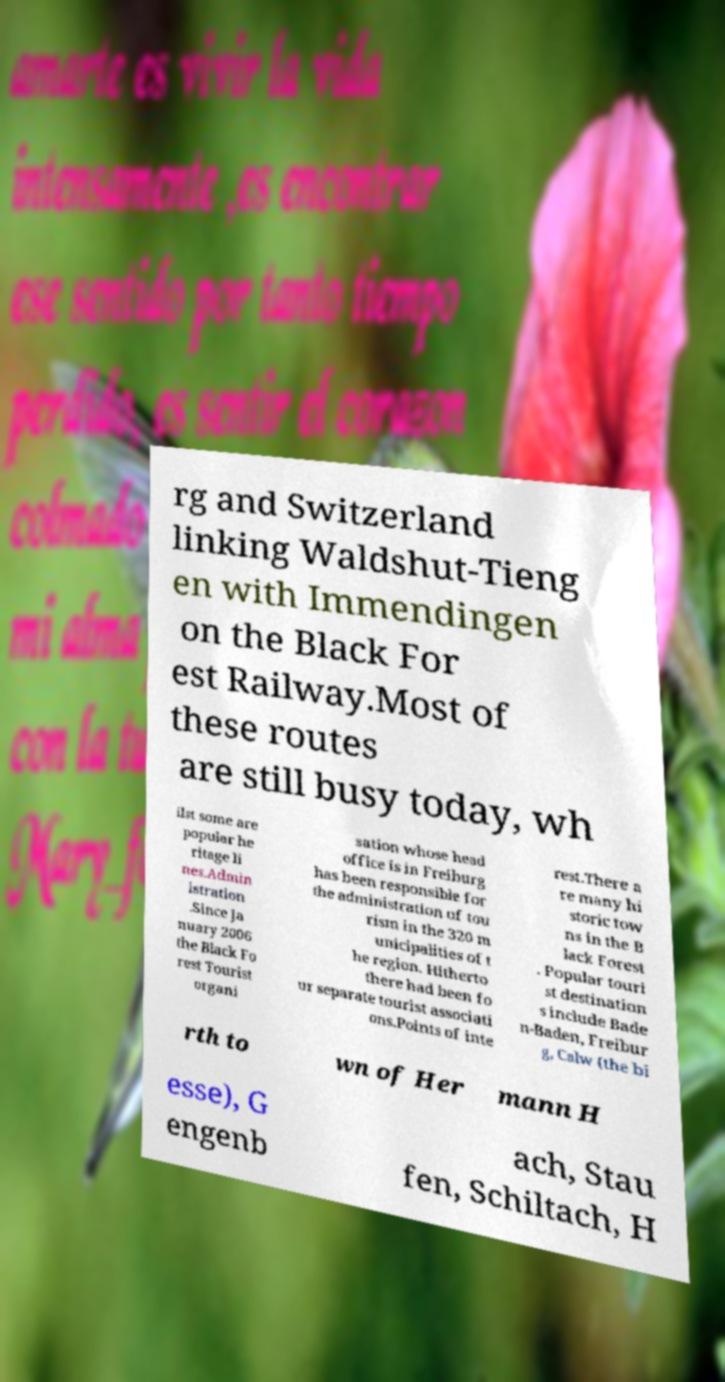Could you assist in decoding the text presented in this image and type it out clearly? rg and Switzerland linking Waldshut-Tieng en with Immendingen on the Black For est Railway.Most of these routes are still busy today, wh ilst some are popular he ritage li nes.Admin istration .Since Ja nuary 2006 the Black Fo rest Tourist organi sation whose head office is in Freiburg has been responsible for the administration of tou rism in the 320 m unicipalities of t he region. Hitherto there had been fo ur separate tourist associati ons.Points of inte rest.There a re many hi storic tow ns in the B lack Forest . Popular touri st destination s include Bade n-Baden, Freibur g, Calw (the bi rth to wn of Her mann H esse), G engenb ach, Stau fen, Schiltach, H 